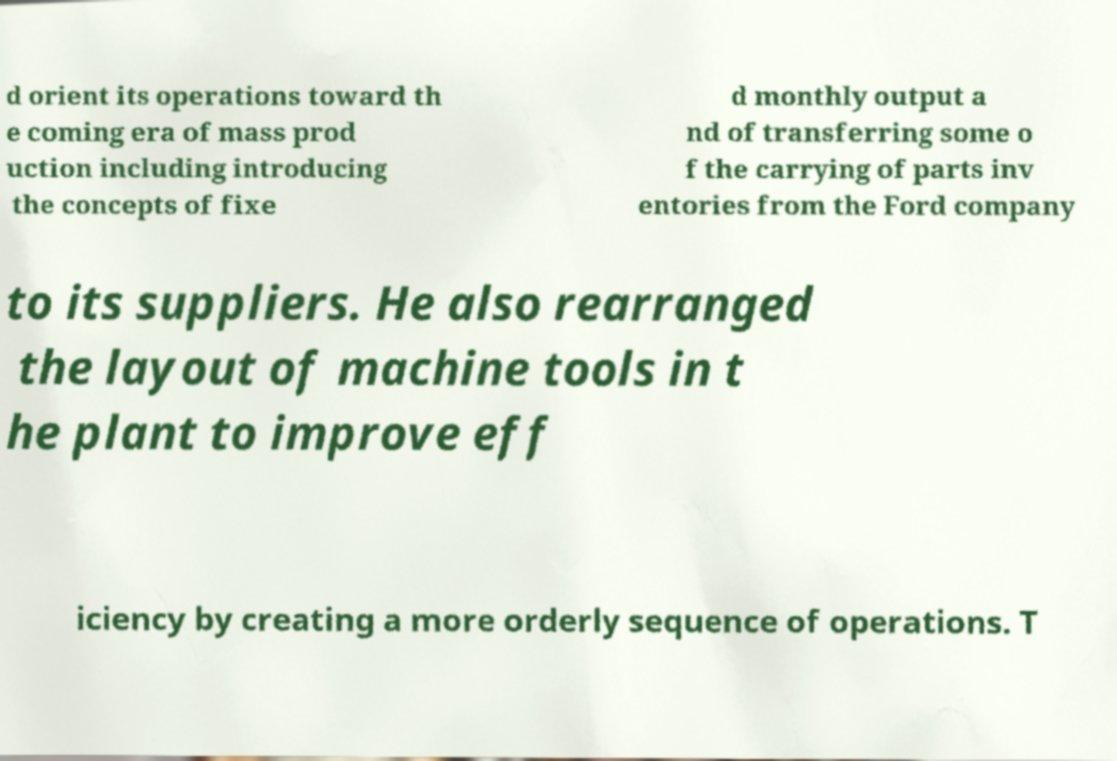There's text embedded in this image that I need extracted. Can you transcribe it verbatim? d orient its operations toward th e coming era of mass prod uction including introducing the concepts of fixe d monthly output a nd of transferring some o f the carrying of parts inv entories from the Ford company to its suppliers. He also rearranged the layout of machine tools in t he plant to improve eff iciency by creating a more orderly sequence of operations. T 